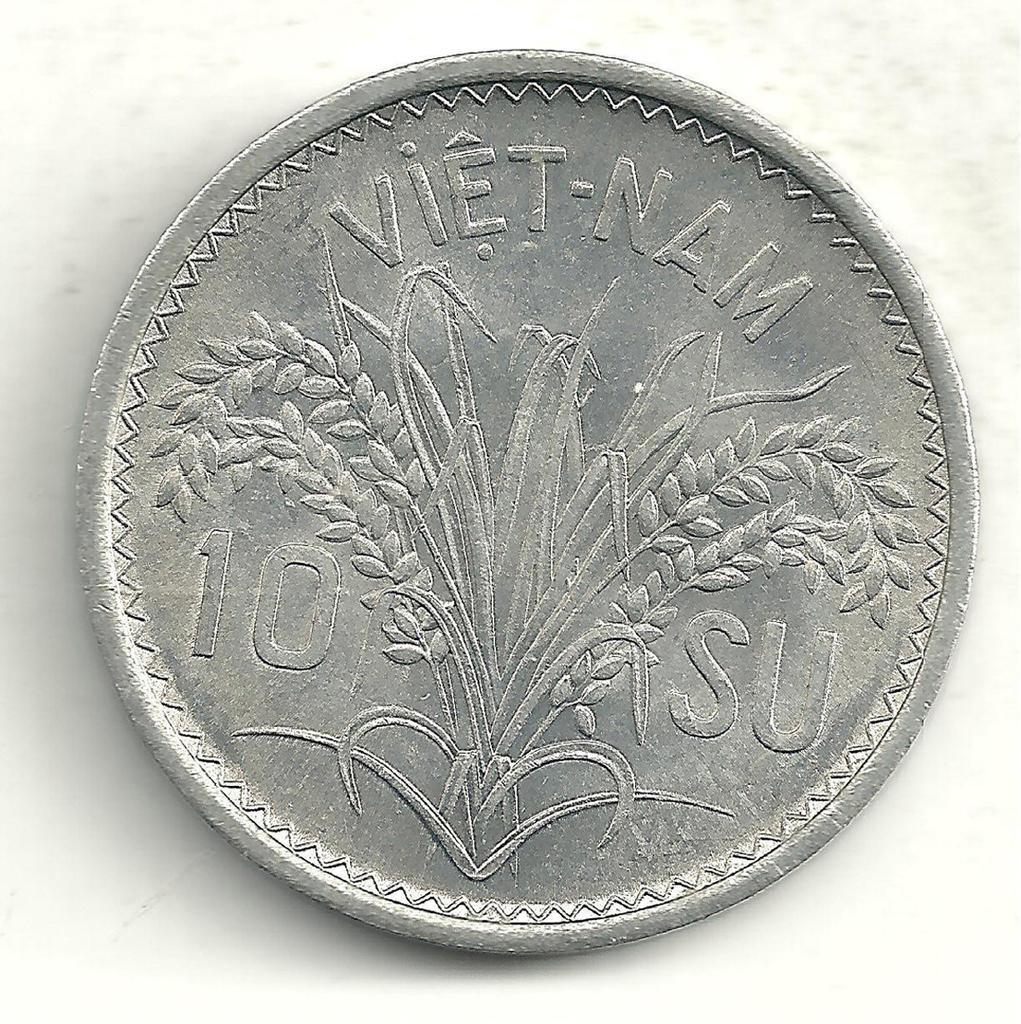Could you give a brief overview of what you see in this image? In the picture there is a currency coin of Vietnam. 